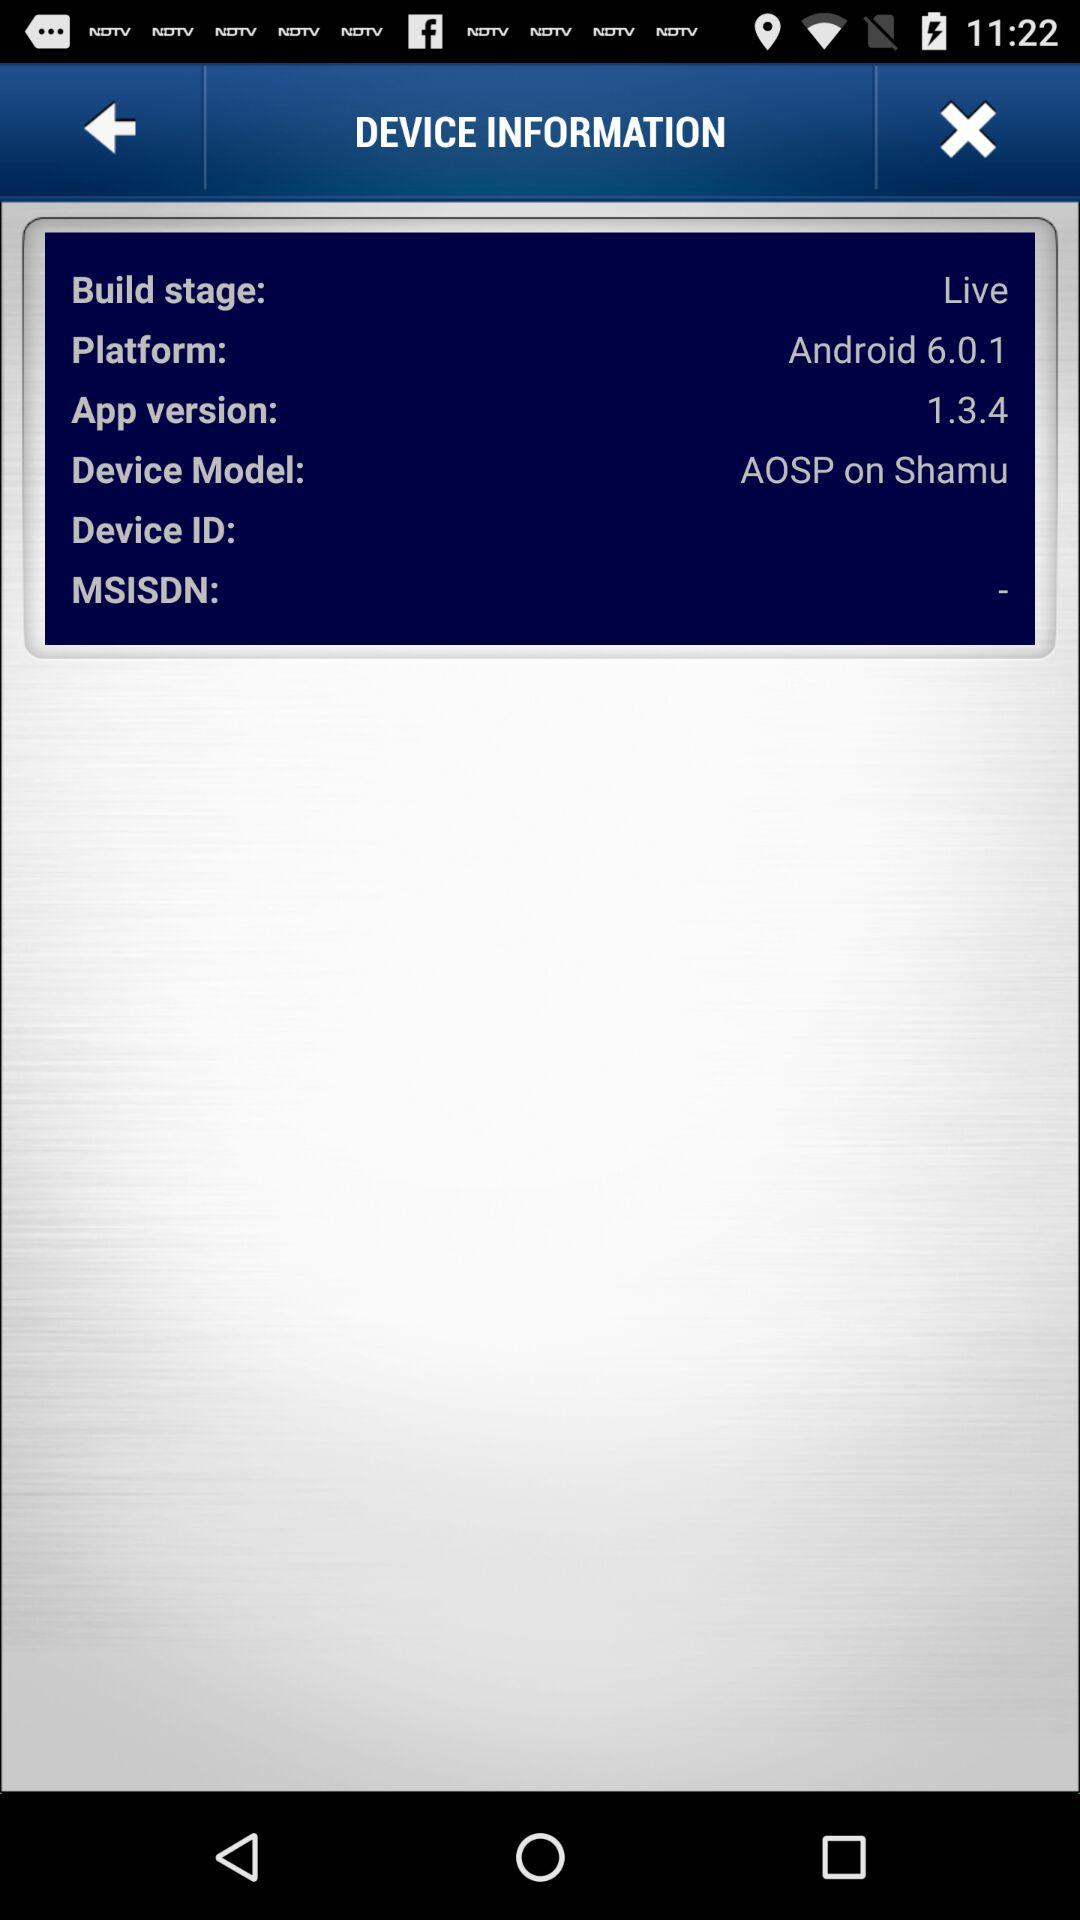What is the device model name? The device model name is AOSP on Shamu. 